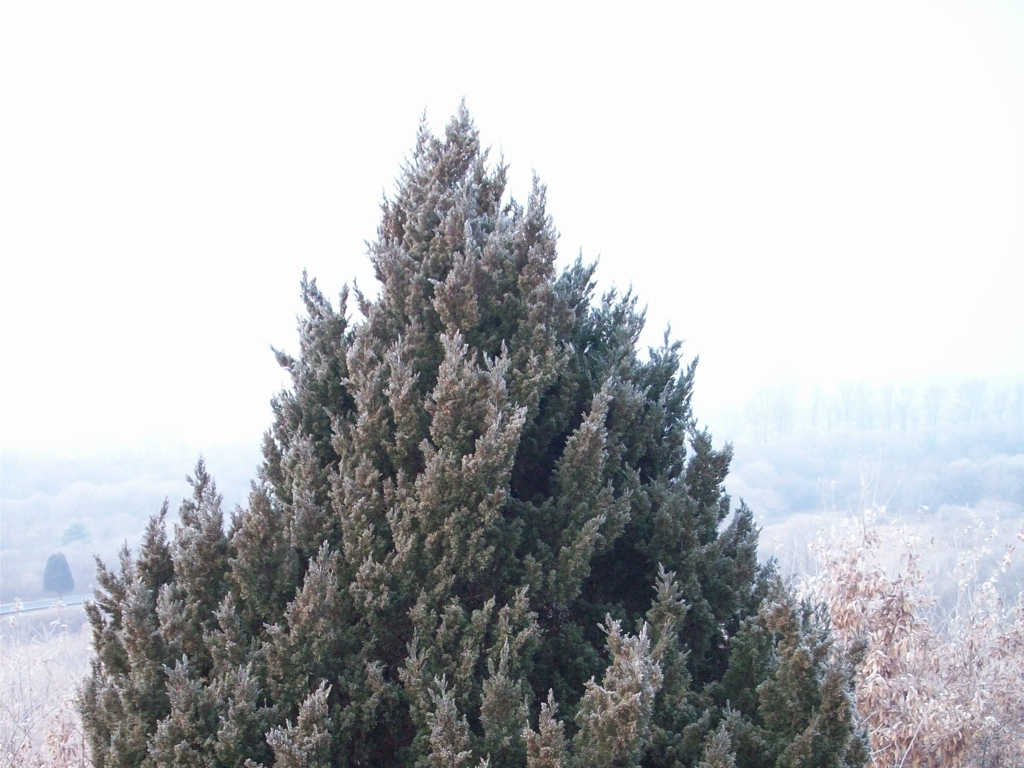Is there any wildlife that might be present in this habitat during the winter? In forested areas with coniferous trees like the one in the image, various wildlife can be found, especially during winter. Birds such as crossbills and chickadees may shelter in the dense branches, while mammals like squirrels and perhaps even deer could be foraging on the ground. The thick foliage of the evergreen trees provides protection from harsh weather and predators, making it a vital habitat for these creatures in wintertime. 